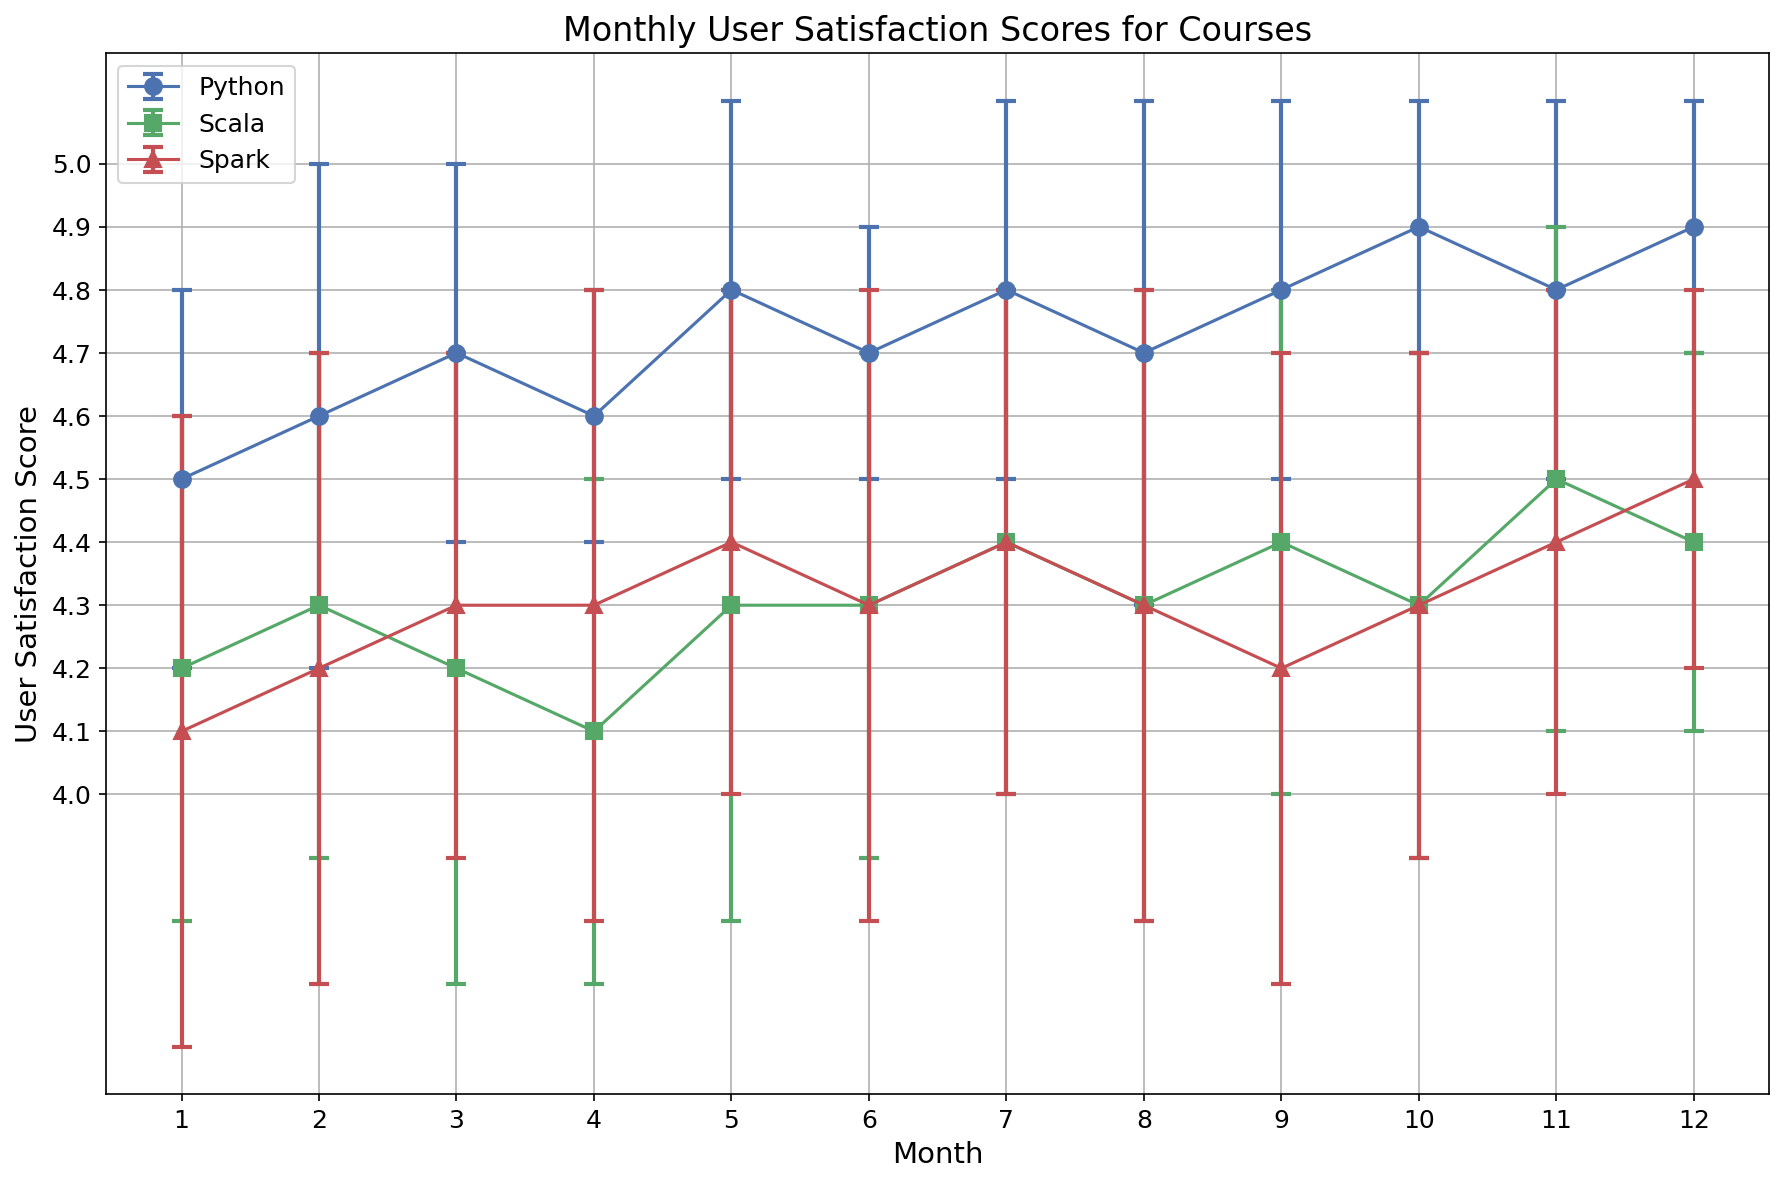Which course had the highest user satisfaction score in any month? By inspecting the figure, identify the course and the month with the highest score.
Answer: Python in Month 12 Which course had the greatest variability in user satisfaction scores over the year? Compare the error bars of each course throughout the months. The course with the largest variability will have the widest error bars more consistently.
Answer: Spark What is the trend of user satisfaction for the Scala course over the year? Observing the trend line for Scala, note any increasing, decreasing, or stable patterns throughout the months.
Answer: Generally stable with slight increases and decreases How does the average satisfaction score of Python in month 6 compare to Scala in the same month? Locate the points for month 6 for both Python and Scala and compare the average satisfaction scores.
Answer: Python has a higher score Which course showed the most improvement in user satisfaction score from month 1 to month 12? Calculate the difference between the month 12 score and the month 1 score for each course and compare the differences.
Answer: Spark What is the average user satisfaction score for the Python course over the entire year? Sum the monthly average scores for Python and divide by 12.
Answer: 4.75 In which month did the Spark course have its lowest user satisfaction score? Identify the lowest point on the trend line for Spark.
Answer: Month 1 Are there any months where the user satisfaction scores for all three courses overlap within their error bars? Inspect the error bars of each course for each month to see if they overlap.
Answer: Yes, in several months including month 10 What is the relative change in user satisfaction for the Spark course between month 3 and month 9? Calculate the percentage change between these two months for Spark.
Answer: Approximately -2.33% Which course had the smallest error bar in any month, indicating the least variability in user satisfaction for that month? Examine the size of the error bars for all courses across all months and find the smallest one.
Answer: Python in Month 4 